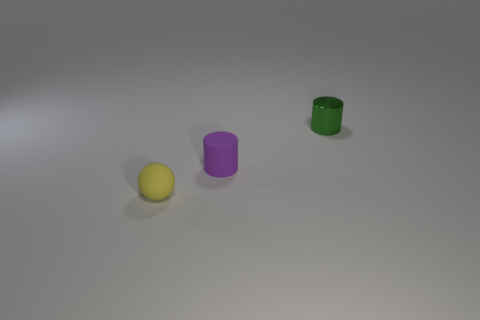There is a small matte thing that is behind the tiny yellow sphere; is it the same shape as the yellow matte object?
Keep it short and to the point. No. Are there more matte cylinders that are to the right of the yellow rubber sphere than objects to the right of the tiny green shiny cylinder?
Offer a terse response. Yes. How many green metal cylinders are to the right of the green metallic object behind the small purple cylinder?
Offer a terse response. 0. What number of other objects are the same color as the tiny rubber sphere?
Your answer should be very brief. 0. There is a small cylinder on the left side of the small cylinder behind the tiny purple cylinder; what is its color?
Make the answer very short. Purple. Is there a small matte cube that has the same color as the small metallic cylinder?
Provide a short and direct response. No. Are there the same number of tiny rubber things and small metal things?
Give a very brief answer. No. What number of shiny things are either yellow objects or cylinders?
Provide a succinct answer. 1. Is there a yellow object made of the same material as the purple object?
Your response must be concise. Yes. How many tiny things are behind the purple matte object and left of the green shiny thing?
Give a very brief answer. 0. 